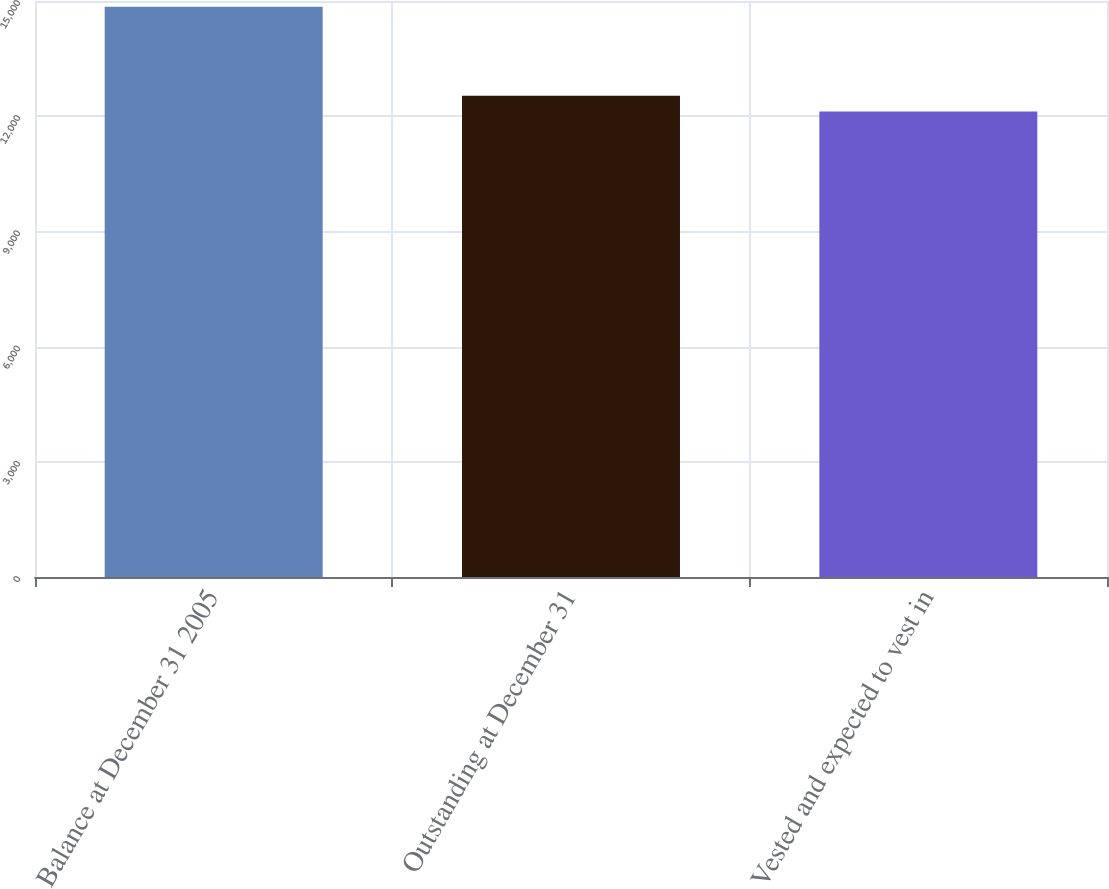Convert chart. <chart><loc_0><loc_0><loc_500><loc_500><bar_chart><fcel>Balance at December 31 2005<fcel>Outstanding at December 31<fcel>Vested and expected to vest in<nl><fcel>14850<fcel>12534<fcel>12123<nl></chart> 